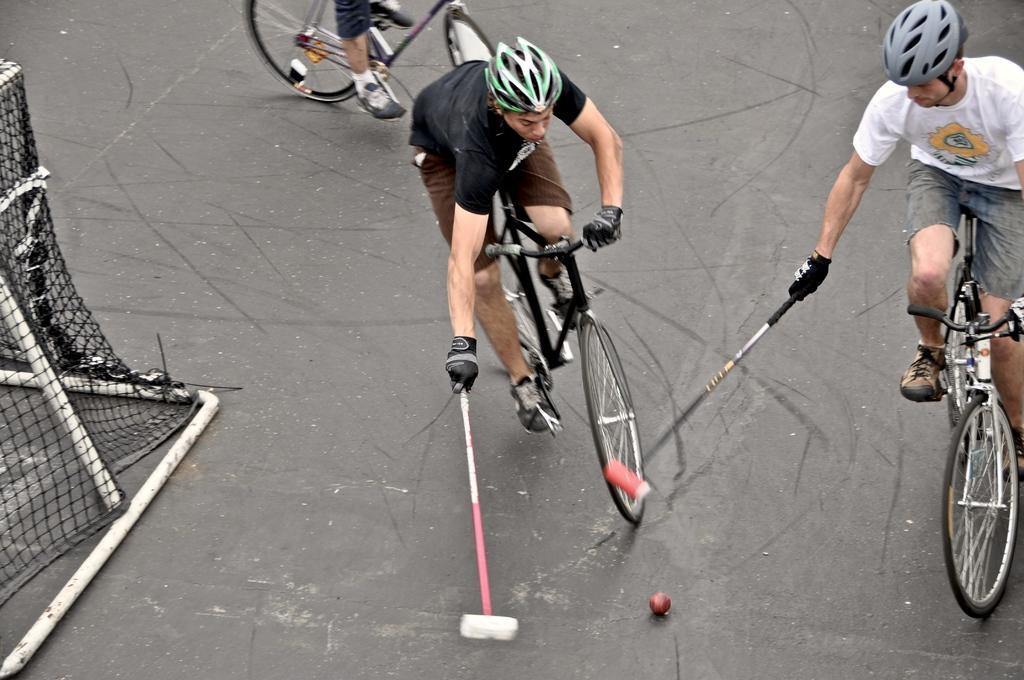Describe this image in one or two sentences. This picture is clicked outside. In the center we can see the group of persons playing bicycle polo by riding the bicycles and holding the mallets and we can see the ball lying on the ground. On the left we can see the metal rods and the net. 